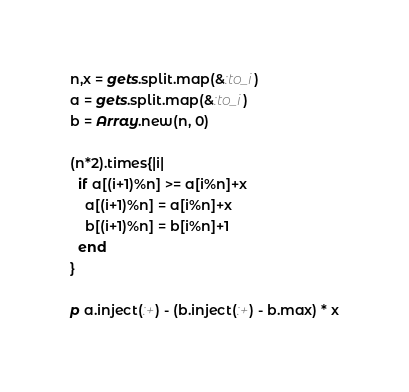<code> <loc_0><loc_0><loc_500><loc_500><_Ruby_>n,x = gets.split.map(&:to_i)
a = gets.split.map(&:to_i)
b = Array.new(n, 0)

(n*2).times{|i|
  if a[(i+1)%n] >= a[i%n]+x
    a[(i+1)%n] = a[i%n]+x
    b[(i+1)%n] = b[i%n]+1
  end
}

p a.inject(:+) - (b.inject(:+) - b.max) * x
</code> 